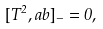Convert formula to latex. <formula><loc_0><loc_0><loc_500><loc_500>[ T ^ { 2 } , a b ] _ { - } = 0 ,</formula> 